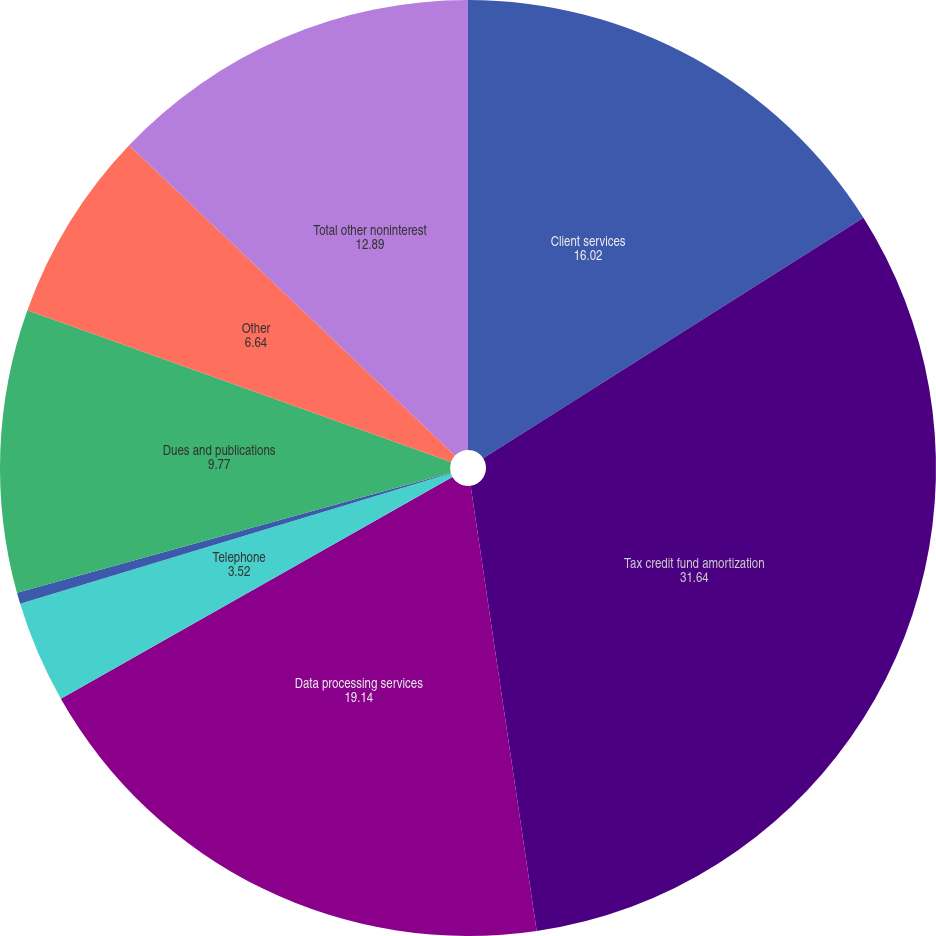Convert chart to OTSL. <chart><loc_0><loc_0><loc_500><loc_500><pie_chart><fcel>Client services<fcel>Tax credit fund amortization<fcel>Data processing services<fcel>Telephone<fcel>Postage and supplies<fcel>Dues and publications<fcel>Other<fcel>Total other noninterest<nl><fcel>16.02%<fcel>31.64%<fcel>19.14%<fcel>3.52%<fcel>0.39%<fcel>9.77%<fcel>6.64%<fcel>12.89%<nl></chart> 